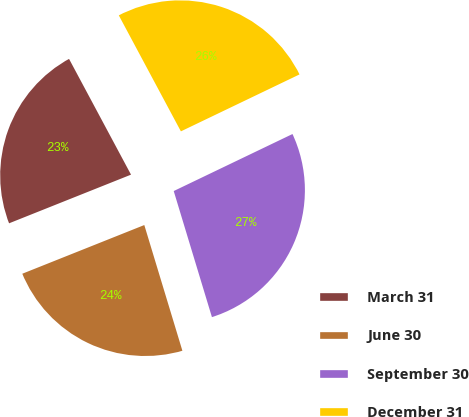Convert chart to OTSL. <chart><loc_0><loc_0><loc_500><loc_500><pie_chart><fcel>March 31<fcel>June 30<fcel>September 30<fcel>December 31<nl><fcel>23.22%<fcel>23.64%<fcel>27.44%<fcel>25.7%<nl></chart> 